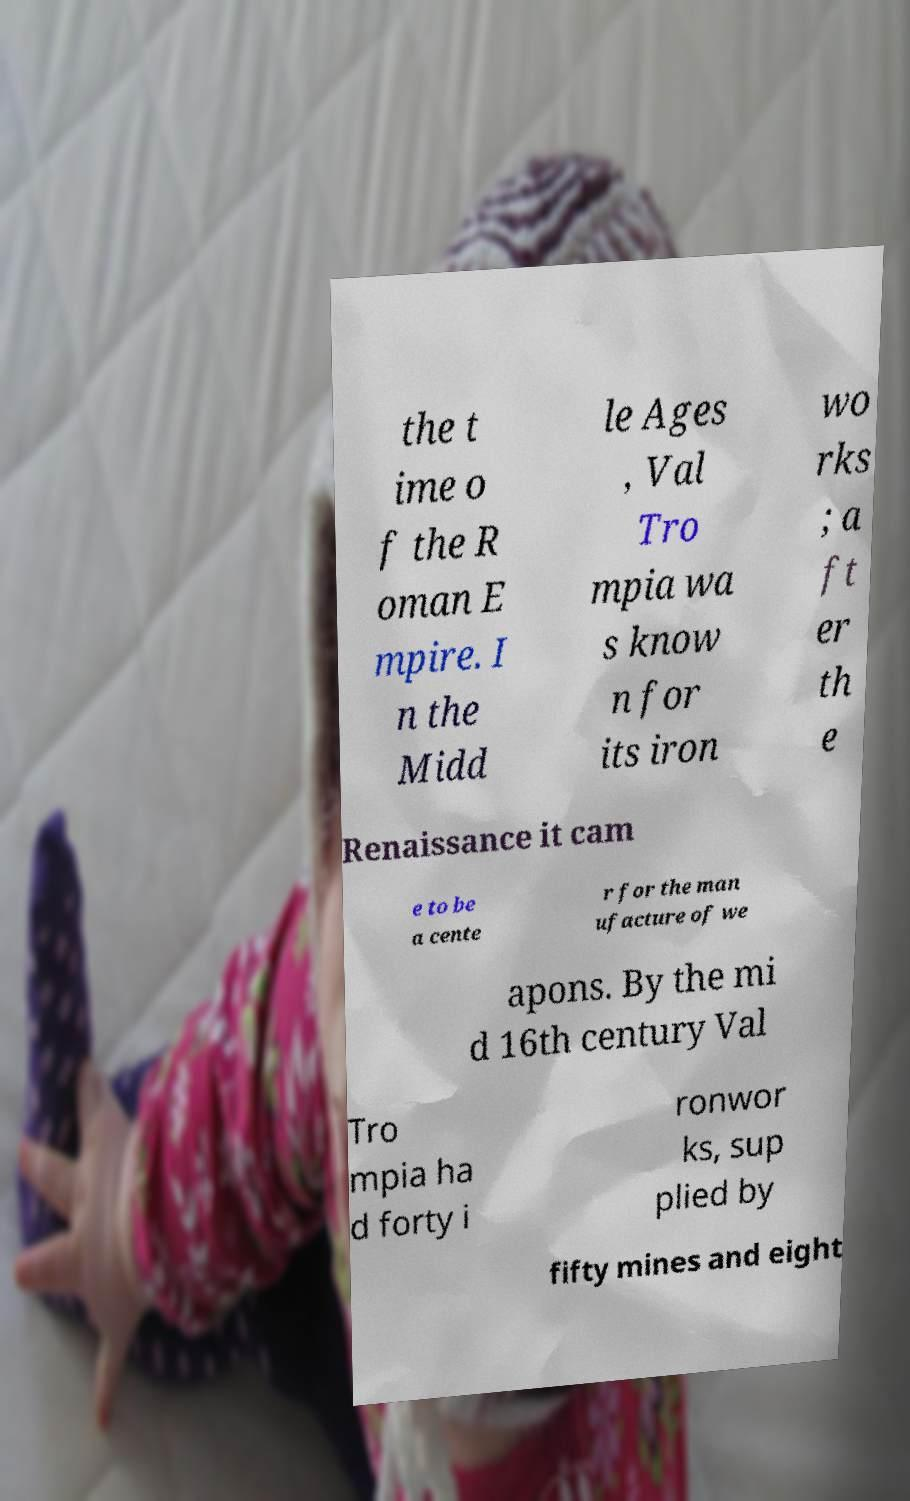Could you assist in decoding the text presented in this image and type it out clearly? the t ime o f the R oman E mpire. I n the Midd le Ages , Val Tro mpia wa s know n for its iron wo rks ; a ft er th e Renaissance it cam e to be a cente r for the man ufacture of we apons. By the mi d 16th century Val Tro mpia ha d forty i ronwor ks, sup plied by fifty mines and eight 